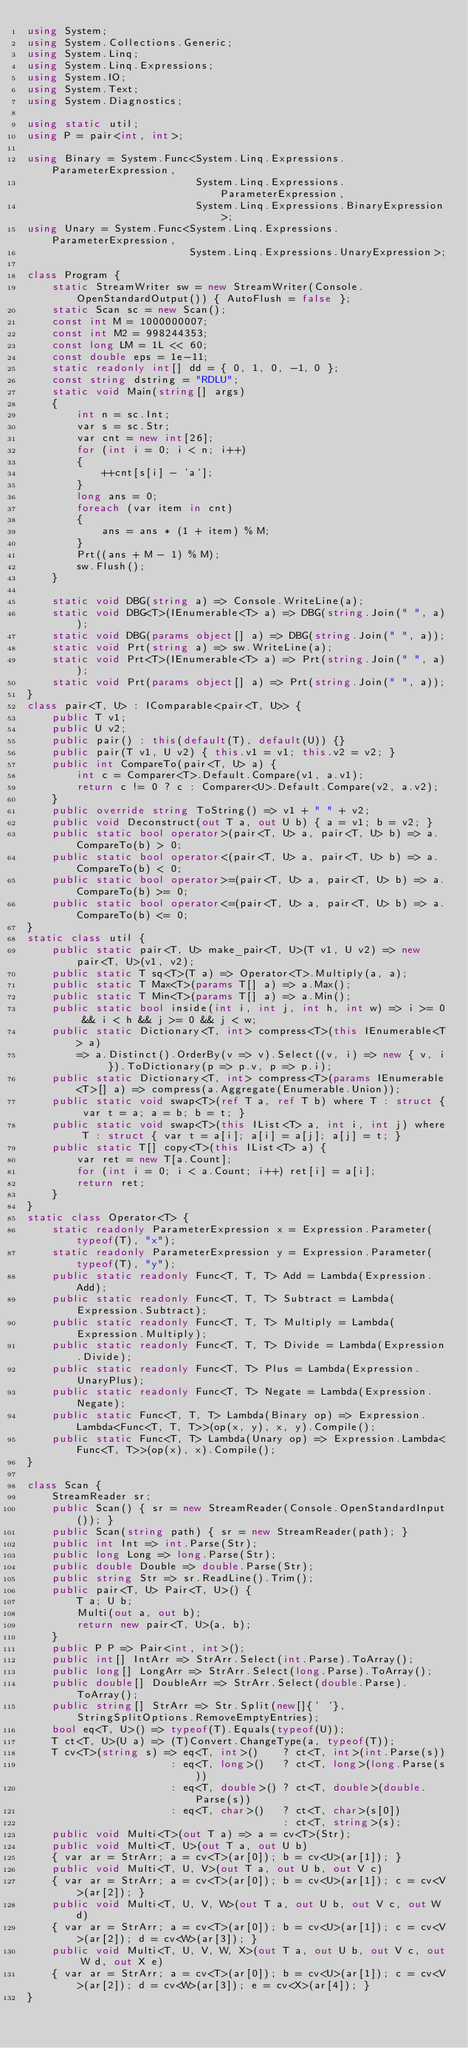<code> <loc_0><loc_0><loc_500><loc_500><_C#_>using System;
using System.Collections.Generic;
using System.Linq;
using System.Linq.Expressions;
using System.IO;
using System.Text;
using System.Diagnostics;

using static util;
using P = pair<int, int>;

using Binary = System.Func<System.Linq.Expressions.ParameterExpression,
                           System.Linq.Expressions.ParameterExpression,
                           System.Linq.Expressions.BinaryExpression>;
using Unary = System.Func<System.Linq.Expressions.ParameterExpression,
                          System.Linq.Expressions.UnaryExpression>;

class Program {
    static StreamWriter sw = new StreamWriter(Console.OpenStandardOutput()) { AutoFlush = false };
    static Scan sc = new Scan();
    const int M = 1000000007;
    const int M2 = 998244353;
    const long LM = 1L << 60;
    const double eps = 1e-11;
    static readonly int[] dd = { 0, 1, 0, -1, 0 };
    const string dstring = "RDLU";
    static void Main(string[] args)
    {
        int n = sc.Int;
        var s = sc.Str;
        var cnt = new int[26];
        for (int i = 0; i < n; i++)
        {
            ++cnt[s[i] - 'a'];
        }
        long ans = 0;
        foreach (var item in cnt)
        {
            ans = ans * (1 + item) % M;
        }
        Prt((ans + M - 1) % M);
        sw.Flush();
    }

    static void DBG(string a) => Console.WriteLine(a);
    static void DBG<T>(IEnumerable<T> a) => DBG(string.Join(" ", a));
    static void DBG(params object[] a) => DBG(string.Join(" ", a));
    static void Prt(string a) => sw.WriteLine(a);
    static void Prt<T>(IEnumerable<T> a) => Prt(string.Join(" ", a));
    static void Prt(params object[] a) => Prt(string.Join(" ", a));
}
class pair<T, U> : IComparable<pair<T, U>> {
    public T v1;
    public U v2;
    public pair() : this(default(T), default(U)) {}
    public pair(T v1, U v2) { this.v1 = v1; this.v2 = v2; }
    public int CompareTo(pair<T, U> a) {
        int c = Comparer<T>.Default.Compare(v1, a.v1);
        return c != 0 ? c : Comparer<U>.Default.Compare(v2, a.v2);
    }
    public override string ToString() => v1 + " " + v2;
    public void Deconstruct(out T a, out U b) { a = v1; b = v2; }
    public static bool operator>(pair<T, U> a, pair<T, U> b) => a.CompareTo(b) > 0;
    public static bool operator<(pair<T, U> a, pair<T, U> b) => a.CompareTo(b) < 0;
    public static bool operator>=(pair<T, U> a, pair<T, U> b) => a.CompareTo(b) >= 0;
    public static bool operator<=(pair<T, U> a, pair<T, U> b) => a.CompareTo(b) <= 0;
}
static class util {
    public static pair<T, U> make_pair<T, U>(T v1, U v2) => new pair<T, U>(v1, v2);
    public static T sq<T>(T a) => Operator<T>.Multiply(a, a);
    public static T Max<T>(params T[] a) => a.Max();
    public static T Min<T>(params T[] a) => a.Min();
    public static bool inside(int i, int j, int h, int w) => i >= 0 && i < h && j >= 0 && j < w;
    public static Dictionary<T, int> compress<T>(this IEnumerable<T> a)
        => a.Distinct().OrderBy(v => v).Select((v, i) => new { v, i }).ToDictionary(p => p.v, p => p.i);
    public static Dictionary<T, int> compress<T>(params IEnumerable<T>[] a) => compress(a.Aggregate(Enumerable.Union));
    public static void swap<T>(ref T a, ref T b) where T : struct { var t = a; a = b; b = t; }
    public static void swap<T>(this IList<T> a, int i, int j) where T : struct { var t = a[i]; a[i] = a[j]; a[j] = t; }
    public static T[] copy<T>(this IList<T> a) {
        var ret = new T[a.Count];
        for (int i = 0; i < a.Count; i++) ret[i] = a[i];
        return ret;
    }
}
static class Operator<T> {
    static readonly ParameterExpression x = Expression.Parameter(typeof(T), "x");
    static readonly ParameterExpression y = Expression.Parameter(typeof(T), "y");
    public static readonly Func<T, T, T> Add = Lambda(Expression.Add);
    public static readonly Func<T, T, T> Subtract = Lambda(Expression.Subtract);
    public static readonly Func<T, T, T> Multiply = Lambda(Expression.Multiply);
    public static readonly Func<T, T, T> Divide = Lambda(Expression.Divide);
    public static readonly Func<T, T> Plus = Lambda(Expression.UnaryPlus);
    public static readonly Func<T, T> Negate = Lambda(Expression.Negate);
    public static Func<T, T, T> Lambda(Binary op) => Expression.Lambda<Func<T, T, T>>(op(x, y), x, y).Compile();
    public static Func<T, T> Lambda(Unary op) => Expression.Lambda<Func<T, T>>(op(x), x).Compile();
}

class Scan {
    StreamReader sr;
    public Scan() { sr = new StreamReader(Console.OpenStandardInput()); }
    public Scan(string path) { sr = new StreamReader(path); }
    public int Int => int.Parse(Str);
    public long Long => long.Parse(Str);
    public double Double => double.Parse(Str);
    public string Str => sr.ReadLine().Trim();
    public pair<T, U> Pair<T, U>() {
        T a; U b;
        Multi(out a, out b);
        return new pair<T, U>(a, b);
    }
    public P P => Pair<int, int>();
    public int[] IntArr => StrArr.Select(int.Parse).ToArray();
    public long[] LongArr => StrArr.Select(long.Parse).ToArray();
    public double[] DoubleArr => StrArr.Select(double.Parse).ToArray();
    public string[] StrArr => Str.Split(new[]{' '}, StringSplitOptions.RemoveEmptyEntries);
    bool eq<T, U>() => typeof(T).Equals(typeof(U));
    T ct<T, U>(U a) => (T)Convert.ChangeType(a, typeof(T));
    T cv<T>(string s) => eq<T, int>()    ? ct<T, int>(int.Parse(s))
                       : eq<T, long>()   ? ct<T, long>(long.Parse(s))
                       : eq<T, double>() ? ct<T, double>(double.Parse(s))
                       : eq<T, char>()   ? ct<T, char>(s[0])
                                         : ct<T, string>(s);
    public void Multi<T>(out T a) => a = cv<T>(Str);
    public void Multi<T, U>(out T a, out U b)
    { var ar = StrArr; a = cv<T>(ar[0]); b = cv<U>(ar[1]); }
    public void Multi<T, U, V>(out T a, out U b, out V c)
    { var ar = StrArr; a = cv<T>(ar[0]); b = cv<U>(ar[1]); c = cv<V>(ar[2]); }
    public void Multi<T, U, V, W>(out T a, out U b, out V c, out W d)
    { var ar = StrArr; a = cv<T>(ar[0]); b = cv<U>(ar[1]); c = cv<V>(ar[2]); d = cv<W>(ar[3]); }
    public void Multi<T, U, V, W, X>(out T a, out U b, out V c, out W d, out X e)
    { var ar = StrArr; a = cv<T>(ar[0]); b = cv<U>(ar[1]); c = cv<V>(ar[2]); d = cv<W>(ar[3]); e = cv<X>(ar[4]); }
}
</code> 